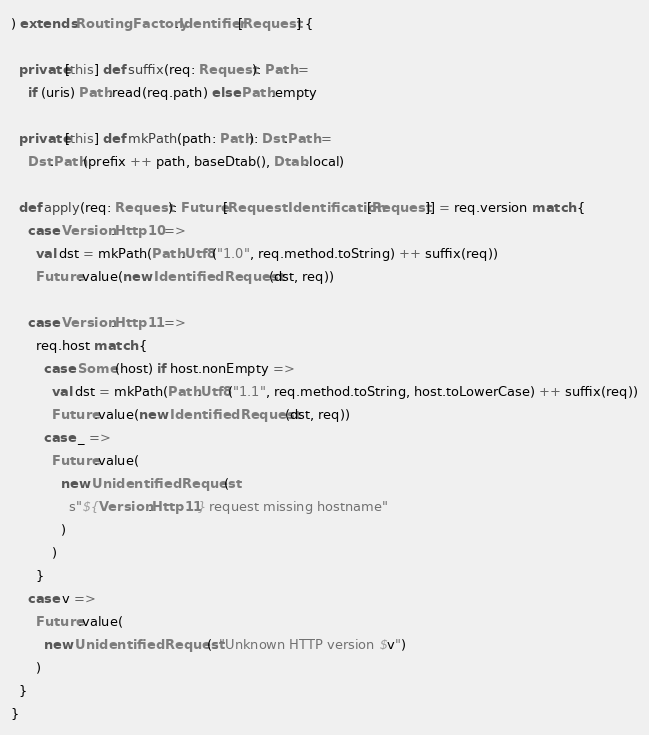Convert code to text. <code><loc_0><loc_0><loc_500><loc_500><_Scala_>) extends RoutingFactory.Identifier[Request] {

  private[this] def suffix(req: Request): Path =
    if (uris) Path.read(req.path) else Path.empty

  private[this] def mkPath(path: Path): Dst.Path =
    Dst.Path(prefix ++ path, baseDtab(), Dtab.local)

  def apply(req: Request): Future[RequestIdentification[Request]] = req.version match {
    case Version.Http10 =>
      val dst = mkPath(Path.Utf8("1.0", req.method.toString) ++ suffix(req))
      Future.value(new IdentifiedRequest(dst, req))

    case Version.Http11 =>
      req.host match {
        case Some(host) if host.nonEmpty =>
          val dst = mkPath(Path.Utf8("1.1", req.method.toString, host.toLowerCase) ++ suffix(req))
          Future.value(new IdentifiedRequest(dst, req))
        case _ =>
          Future.value(
            new UnidentifiedRequest(
              s"${Version.Http11} request missing hostname"
            )
          )
      }
    case v =>
      Future.value(
        new UnidentifiedRequest(s"Unknown HTTP version $v")
      )
  }
}
</code> 